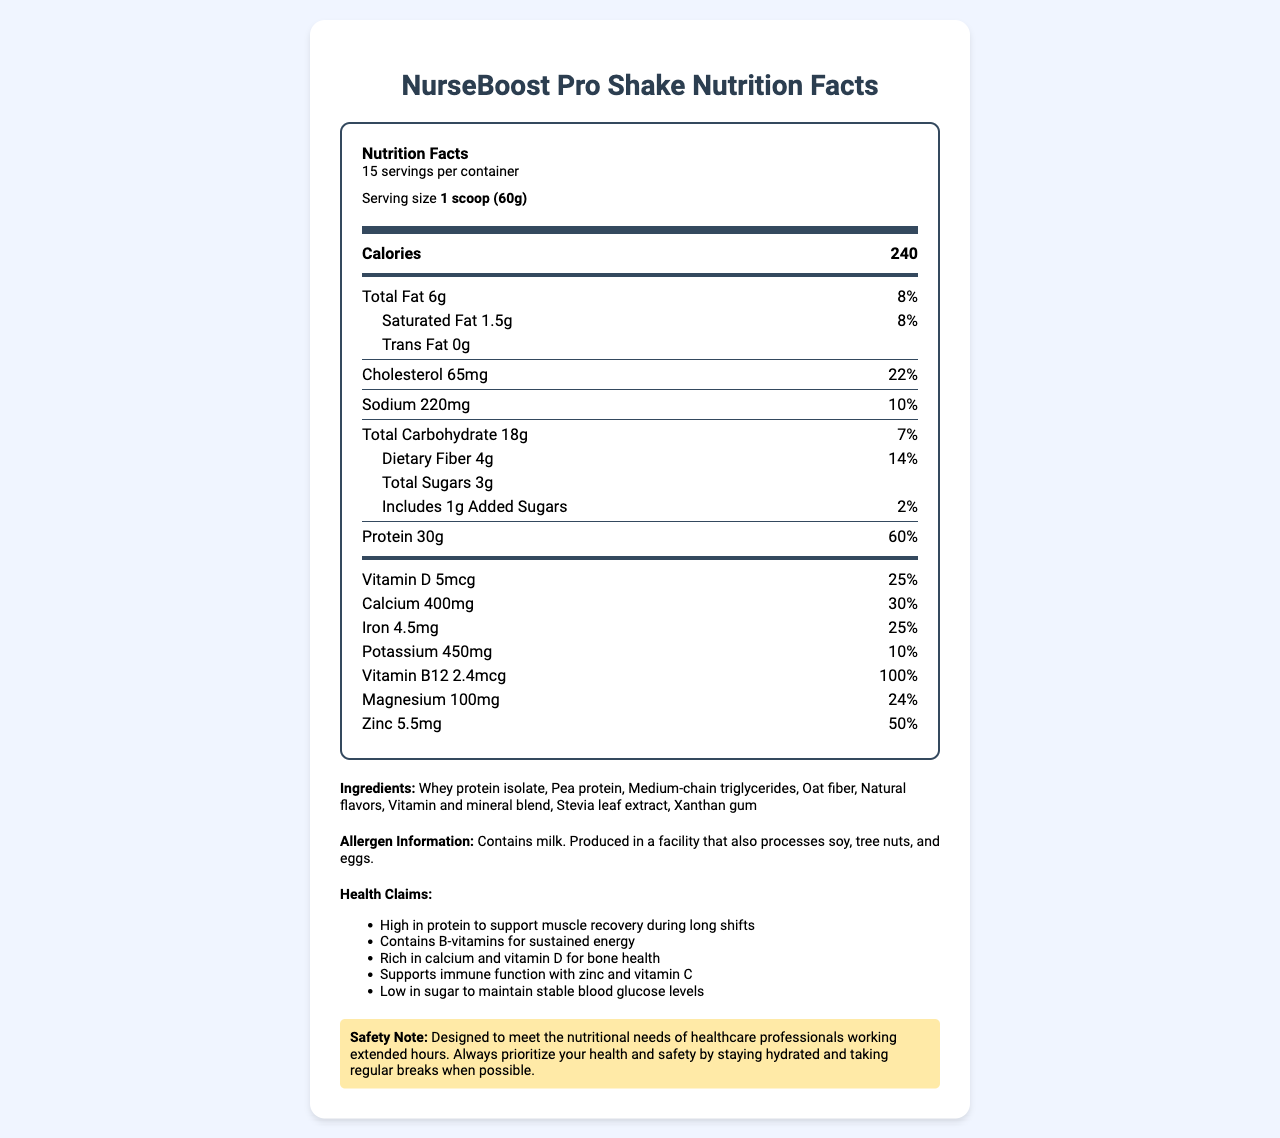what is the serving size? The serving size is clearly stated in the "serving size" field as "1 scoop (60g)".
Answer: 1 scoop (60g) how many servings are in one container? The document specifies that there are 15 servings per container.
Answer: 15 how much protein is in each serving? The nutrition label mentions that each serving contains 30g of protein.
Answer: 30g what is the percentage of daily value for calcium per serving? The daily value percentage for calcium is listed as 30%.
Answer: 30% what are the ingredients used in NurseBoost Pro Shake? The ingredients are listed in the ingredients section.
Answer: Whey protein isolate, Pea protein, Medium-chain triglycerides, Oat fiber, Natural flavors, Vitamin and mineral blend, Stevia leaf extract, Xanthan gum which allergen is present in this product? A. Soy B. Tree nuts C. Milk The allergen information states "Contains milk. Produced in a facility that also processes soy, tree nuts, and eggs."
Answer: C how much sodium does one serving contain? A. 65mg B. 220mg C. 450mg D. 100mg The sodium content per serving is listed as 220mg.
Answer: B is the product high in protein? The product contains 30g of protein per serving, which constitutes 60% of the daily value, indicating it is high in protein.
Answer: Yes how many grams of dietary fiber are in each serving? The nutrition label states that there are 4g of dietary fiber per serving.
Answer: 4g what health benefits does this product claim? The health claims section lists several benefits including high protein content, B-vitamins, calcium and vitamin D, immune function support, and low sugar.
Answer: High in protein to support muscle recovery during long shifts, Contains B-vitamins for sustained energy, Rich in calcium and vitamin D for bone health, Supports immune function with zinc and vitamin C, Low in sugar to maintain stable blood glucose levels what is the daily value percentage of vitamin B12 in each serving? The nutrition facts state that each serving provides 100% of the daily value for vitamin B12.
Answer: 100% is there any trans fat in this product? The label indicates that there is 0g of trans fat per serving.
Answer: No summarize the main information given in this document. This summary includes information about serving size, nutrients, vitamins, minerals, ingredients, health claims, and allergen info, encapsulating the main points from the document.
Answer: The document provides the nutrition facts and other relevant details for the NurseBoost Pro Shake. Each serving size is 1 scoop (60g), and there are 15 servings per container. It contains 240 calories, 6g total fat, 18g carbohydrates, and 30g protein. The shake is high in protein, low in sugar, and includes various vitamins and minerals such as calcium, vitamin D, iron, potassium, vitamin B12, magnesium, and zinc. It lists its ingredients, allergen information (contains milk), and several health claims about muscle recovery, energy, bone health, immune support, and blood glucose stability. Additionally, it includes a safety note emphasizing its design for healthcare professionals' nutritional needs. what is the cost of this product? The document does not provide any information regarding the price of NurseBoost Pro Shake.
Answer: Cannot be determined 